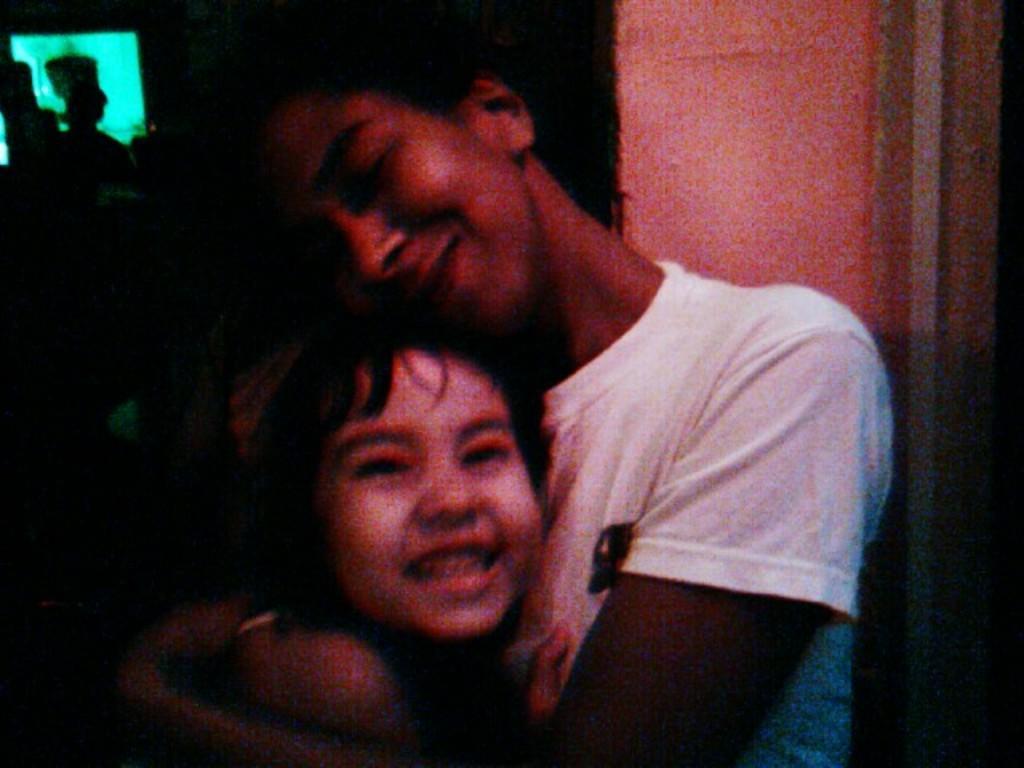In one or two sentences, can you explain what this image depicts? In the image there is a man in white t-shirt holding a baby in front of the wall and the background is dark. 